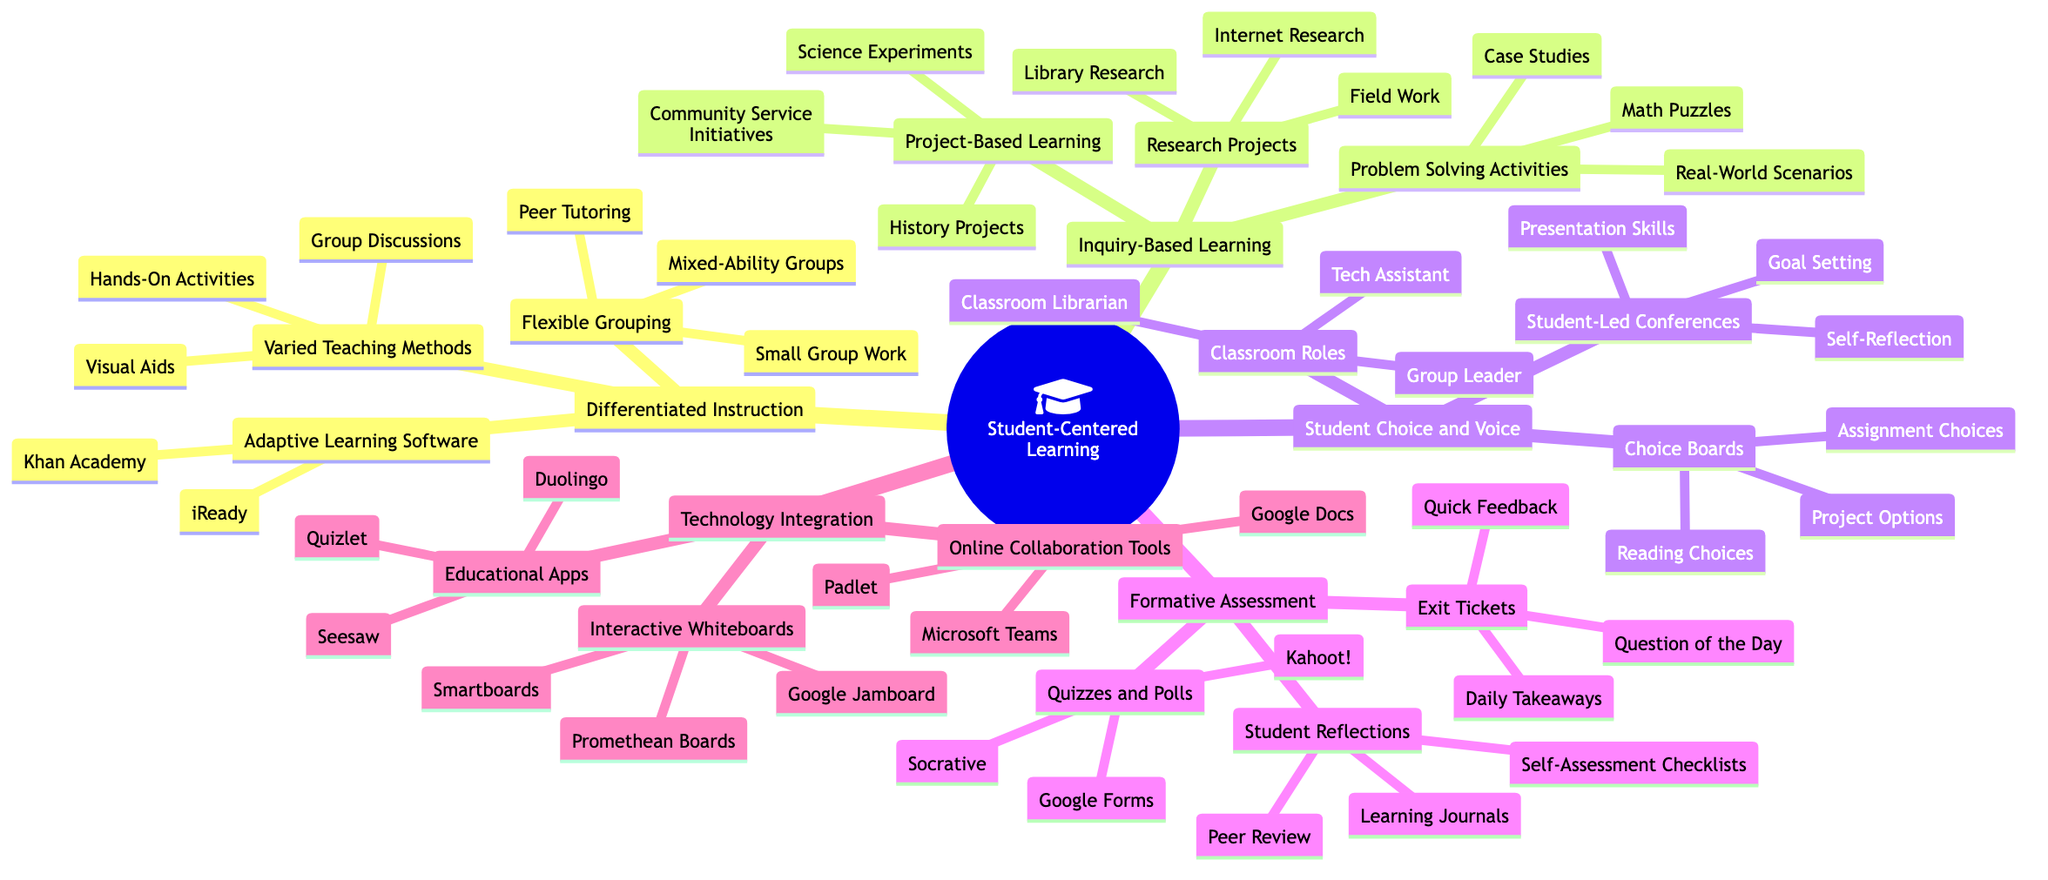What is the main central node of the mind map? The central node of the mind map is the topic that all branches relate to. In this case, it is labeled "Student-Centered Learning."
Answer: Student-Centered Learning How many main branches are there? To find the number of main branches, we count the primary categories that stem from the central node. There are five main branches listed under "Student-Centered Learning."
Answer: 5 What type of activities are included under "Student Choice and Voice"? This question requires identifying the specific activities listed under the "Student Choice and Voice" branch. They include "Student-Led Conferences," "Choice Boards," and "Classroom Roles."
Answer: Student-Led Conferences, Choice Boards, Classroom Roles What are two tools listed under "Adaptive Learning Software"? This question focuses on extracting specific examples from the "Adaptive Learning Software" sub-branch under "Differentiated Instruction." The two tools are "Khan Academy" and "iReady."
Answer: Khan Academy, iReady Which main branch contains "Math Puzzles"? The task is to determine where "Math Puzzles" fits within the broader structure of the mind map. It is found under the "Problem Solving Activities" sub-branch of the "Inquiry-Based Learning" branch.
Answer: Inquiry-Based Learning What is the purpose of "Exit Tickets"? This question probes for a specific action or purpose associated with the "Exit Tickets" listed in the "Formative Assessment" section. They are used for gathering quick feedback and student takeaways for each class.
Answer: Quick feedback How many types of educational apps are listed under "Technology Integration"? To answer this, we need to review the specific sub-branch for educational apps and count how many distinct tools are provided. There are three apps listed: "Duolingo," "Quizlet," and "Seesaw."
Answer: 3 What are the roles listed under "Classroom Roles"? This asks for specifics about the tasks defined under the "Classroom Roles" sub-branch, which are defined as "Classroom Librarian," "Tech Assistant," and "Group Leader."
Answer: Classroom Librarian, Tech Assistant, Group Leader 